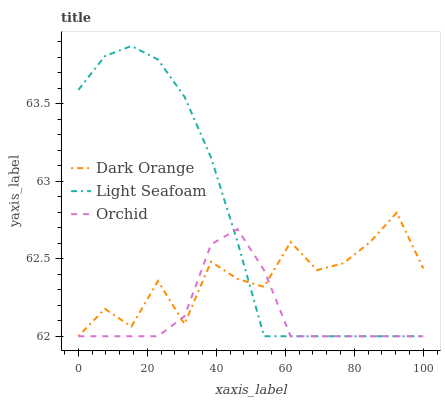Does Orchid have the minimum area under the curve?
Answer yes or no. Yes. Does Light Seafoam have the maximum area under the curve?
Answer yes or no. Yes. Does Light Seafoam have the minimum area under the curve?
Answer yes or no. No. Does Orchid have the maximum area under the curve?
Answer yes or no. No. Is Light Seafoam the smoothest?
Answer yes or no. Yes. Is Dark Orange the roughest?
Answer yes or no. Yes. Is Orchid the smoothest?
Answer yes or no. No. Is Orchid the roughest?
Answer yes or no. No. Does Dark Orange have the lowest value?
Answer yes or no. Yes. Does Light Seafoam have the highest value?
Answer yes or no. Yes. Does Orchid have the highest value?
Answer yes or no. No. Does Dark Orange intersect Orchid?
Answer yes or no. Yes. Is Dark Orange less than Orchid?
Answer yes or no. No. Is Dark Orange greater than Orchid?
Answer yes or no. No. 